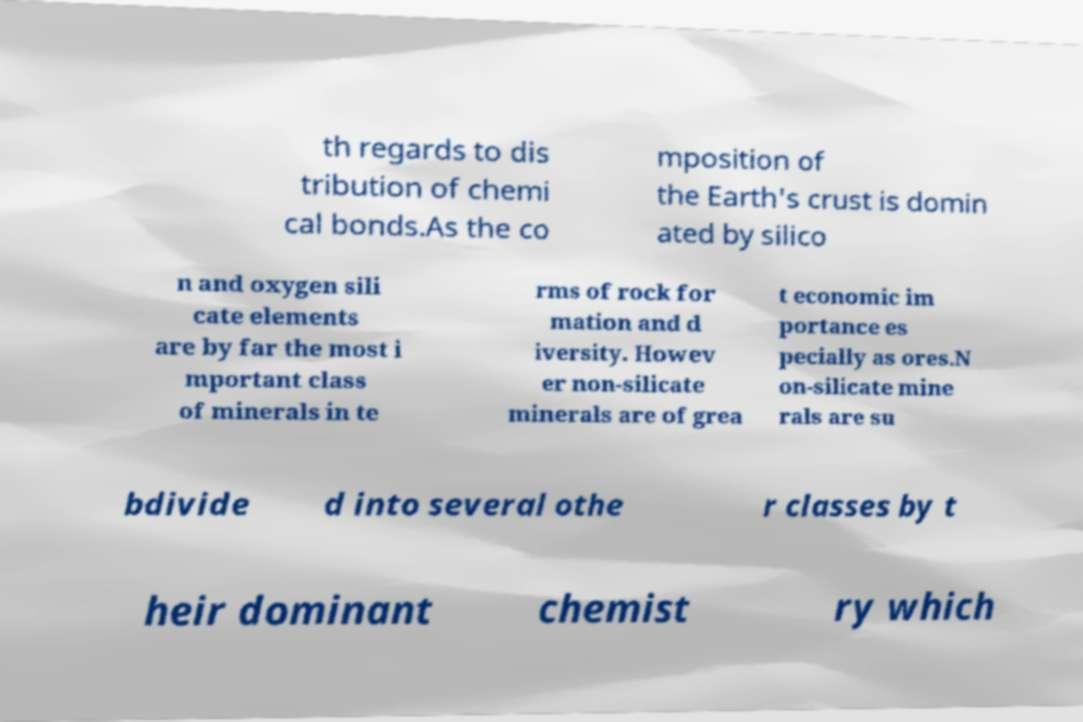For documentation purposes, I need the text within this image transcribed. Could you provide that? th regards to dis tribution of chemi cal bonds.As the co mposition of the Earth's crust is domin ated by silico n and oxygen sili cate elements are by far the most i mportant class of minerals in te rms of rock for mation and d iversity. Howev er non-silicate minerals are of grea t economic im portance es pecially as ores.N on-silicate mine rals are su bdivide d into several othe r classes by t heir dominant chemist ry which 